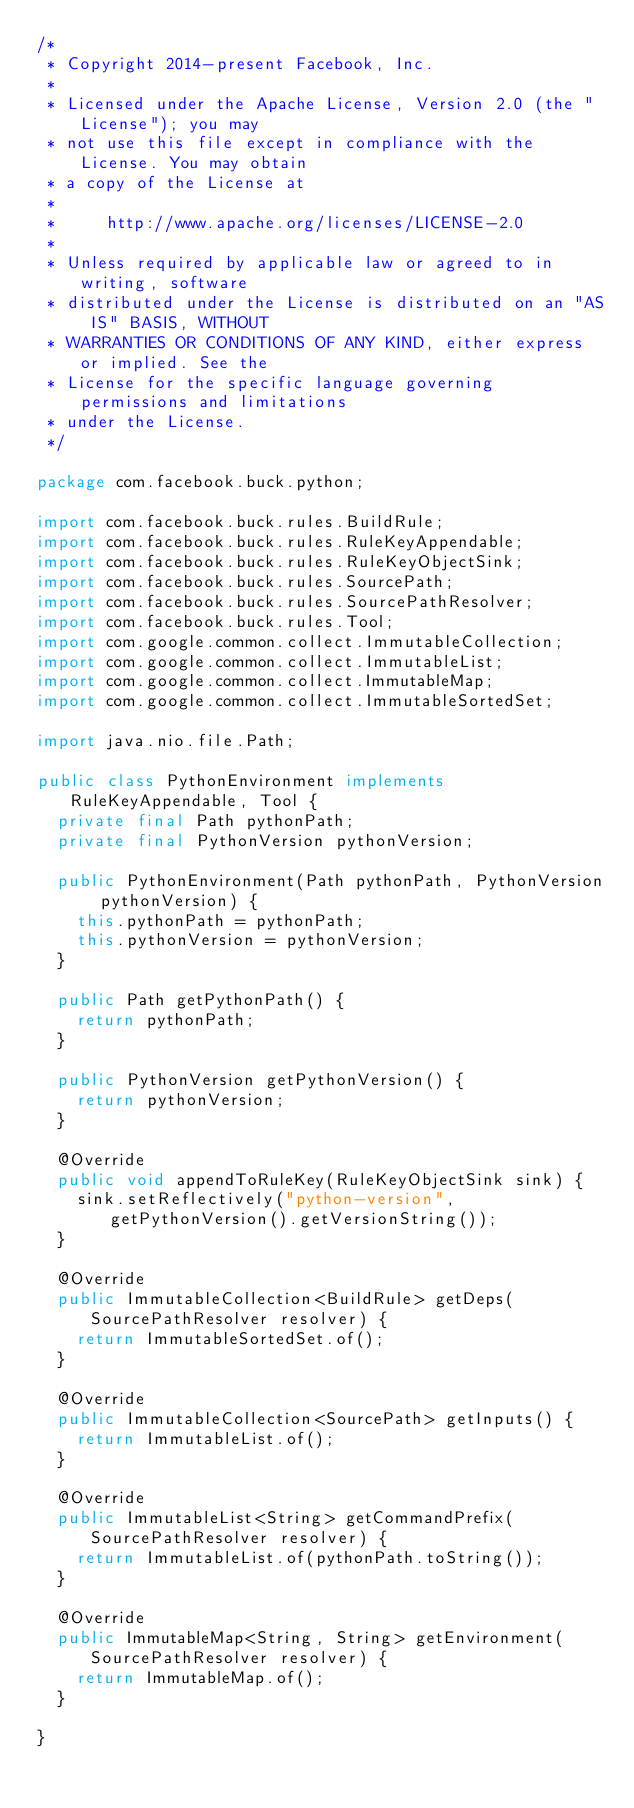Convert code to text. <code><loc_0><loc_0><loc_500><loc_500><_Java_>/*
 * Copyright 2014-present Facebook, Inc.
 *
 * Licensed under the Apache License, Version 2.0 (the "License"); you may
 * not use this file except in compliance with the License. You may obtain
 * a copy of the License at
 *
 *     http://www.apache.org/licenses/LICENSE-2.0
 *
 * Unless required by applicable law or agreed to in writing, software
 * distributed under the License is distributed on an "AS IS" BASIS, WITHOUT
 * WARRANTIES OR CONDITIONS OF ANY KIND, either express or implied. See the
 * License for the specific language governing permissions and limitations
 * under the License.
 */

package com.facebook.buck.python;

import com.facebook.buck.rules.BuildRule;
import com.facebook.buck.rules.RuleKeyAppendable;
import com.facebook.buck.rules.RuleKeyObjectSink;
import com.facebook.buck.rules.SourcePath;
import com.facebook.buck.rules.SourcePathResolver;
import com.facebook.buck.rules.Tool;
import com.google.common.collect.ImmutableCollection;
import com.google.common.collect.ImmutableList;
import com.google.common.collect.ImmutableMap;
import com.google.common.collect.ImmutableSortedSet;

import java.nio.file.Path;

public class PythonEnvironment implements RuleKeyAppendable, Tool {
  private final Path pythonPath;
  private final PythonVersion pythonVersion;

  public PythonEnvironment(Path pythonPath, PythonVersion pythonVersion) {
    this.pythonPath = pythonPath;
    this.pythonVersion = pythonVersion;
  }

  public Path getPythonPath() {
    return pythonPath;
  }

  public PythonVersion getPythonVersion() {
    return pythonVersion;
  }

  @Override
  public void appendToRuleKey(RuleKeyObjectSink sink) {
    sink.setReflectively("python-version", getPythonVersion().getVersionString());
  }

  @Override
  public ImmutableCollection<BuildRule> getDeps(SourcePathResolver resolver) {
    return ImmutableSortedSet.of();
  }

  @Override
  public ImmutableCollection<SourcePath> getInputs() {
    return ImmutableList.of();
  }

  @Override
  public ImmutableList<String> getCommandPrefix(SourcePathResolver resolver) {
    return ImmutableList.of(pythonPath.toString());
  }

  @Override
  public ImmutableMap<String, String> getEnvironment(SourcePathResolver resolver) {
    return ImmutableMap.of();
  }

}
</code> 